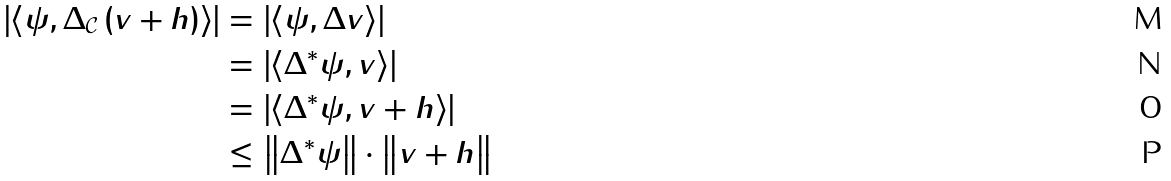<formula> <loc_0><loc_0><loc_500><loc_500>\left | \left \langle \psi , \Delta _ { \mathcal { C } } \left ( v + h \right ) \right \rangle \right | & = \left | \left \langle \psi , \Delta v \right \rangle \right | \\ & = \left | \left \langle \Delta ^ { \ast } \psi , v \right \rangle \right | \\ & = \left | \left \langle \Delta ^ { \ast } \psi , v + h \right \rangle \right | \\ & \leq \left \| \Delta ^ { \ast } \psi \right \| \cdot \left \| v + h \right \|</formula> 